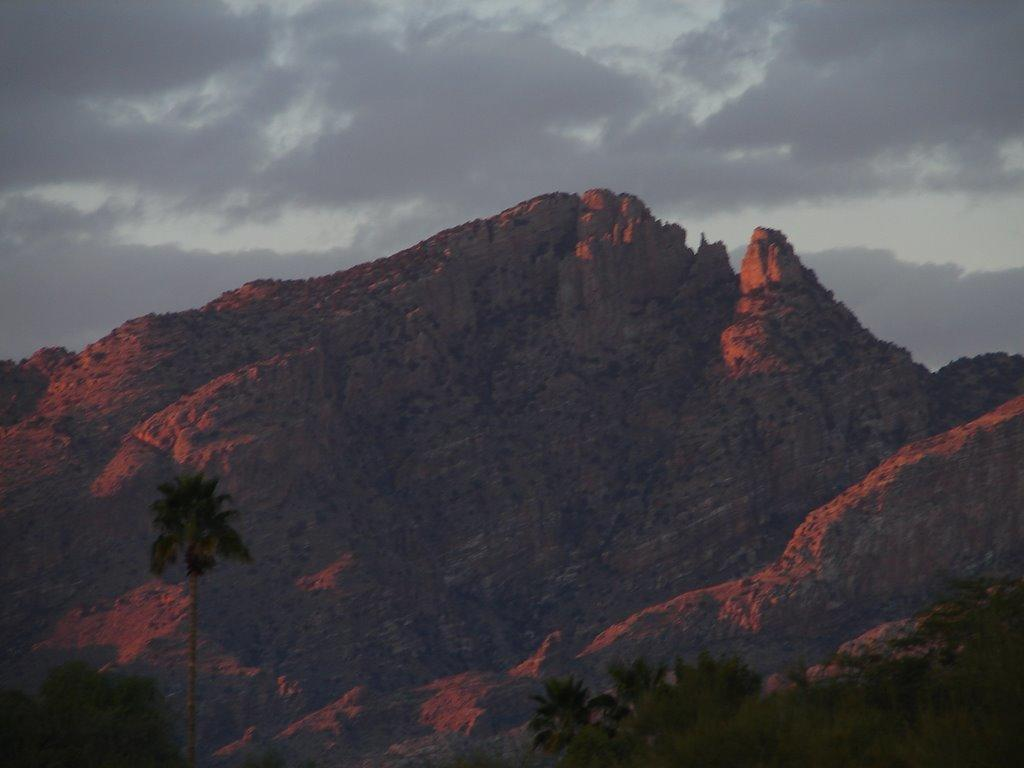What type of vegetation is at the bottom of the image? There are trees at the bottom of the image. What geographical features are in the middle of the image? There are hills in the middle of the image. What is visible at the top of the image? The sky is visible at the top of the image. Can you see the maid jumping over the trees in the image? There is no maid or jumping activity present in the image; it features trees, hills, and the sky. What type of detail can be seen on the trees in the image? The trees in the image do not have any visible details that can be described. 